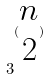<formula> <loc_0><loc_0><loc_500><loc_500>3 ^ { ( \begin{matrix} n \\ 2 \end{matrix} ) }</formula> 